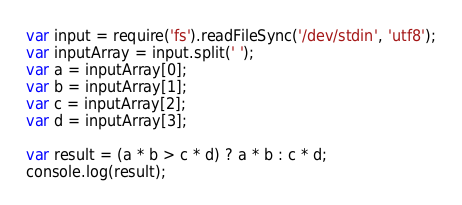Convert code to text. <code><loc_0><loc_0><loc_500><loc_500><_JavaScript_>var input = require('fs').readFileSync('/dev/stdin', 'utf8');
var inputArray = input.split(' ');
var a = inputArray[0];
var b = inputArray[1];
var c = inputArray[2];
var d = inputArray[3];

var result = (a * b > c * d) ? a * b : c * d;
console.log(result);</code> 